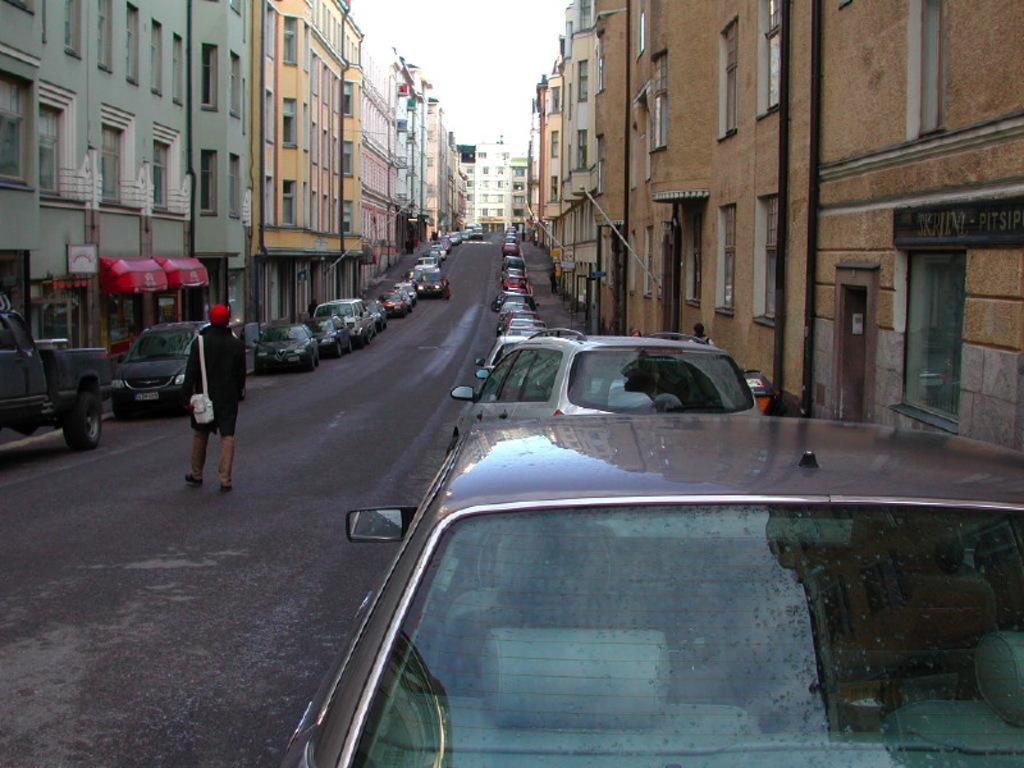Please provide a concise description of this image. In this image, we can see some cars in between buildings. There is a person walking on the road. There is a sky at the top of the image. 